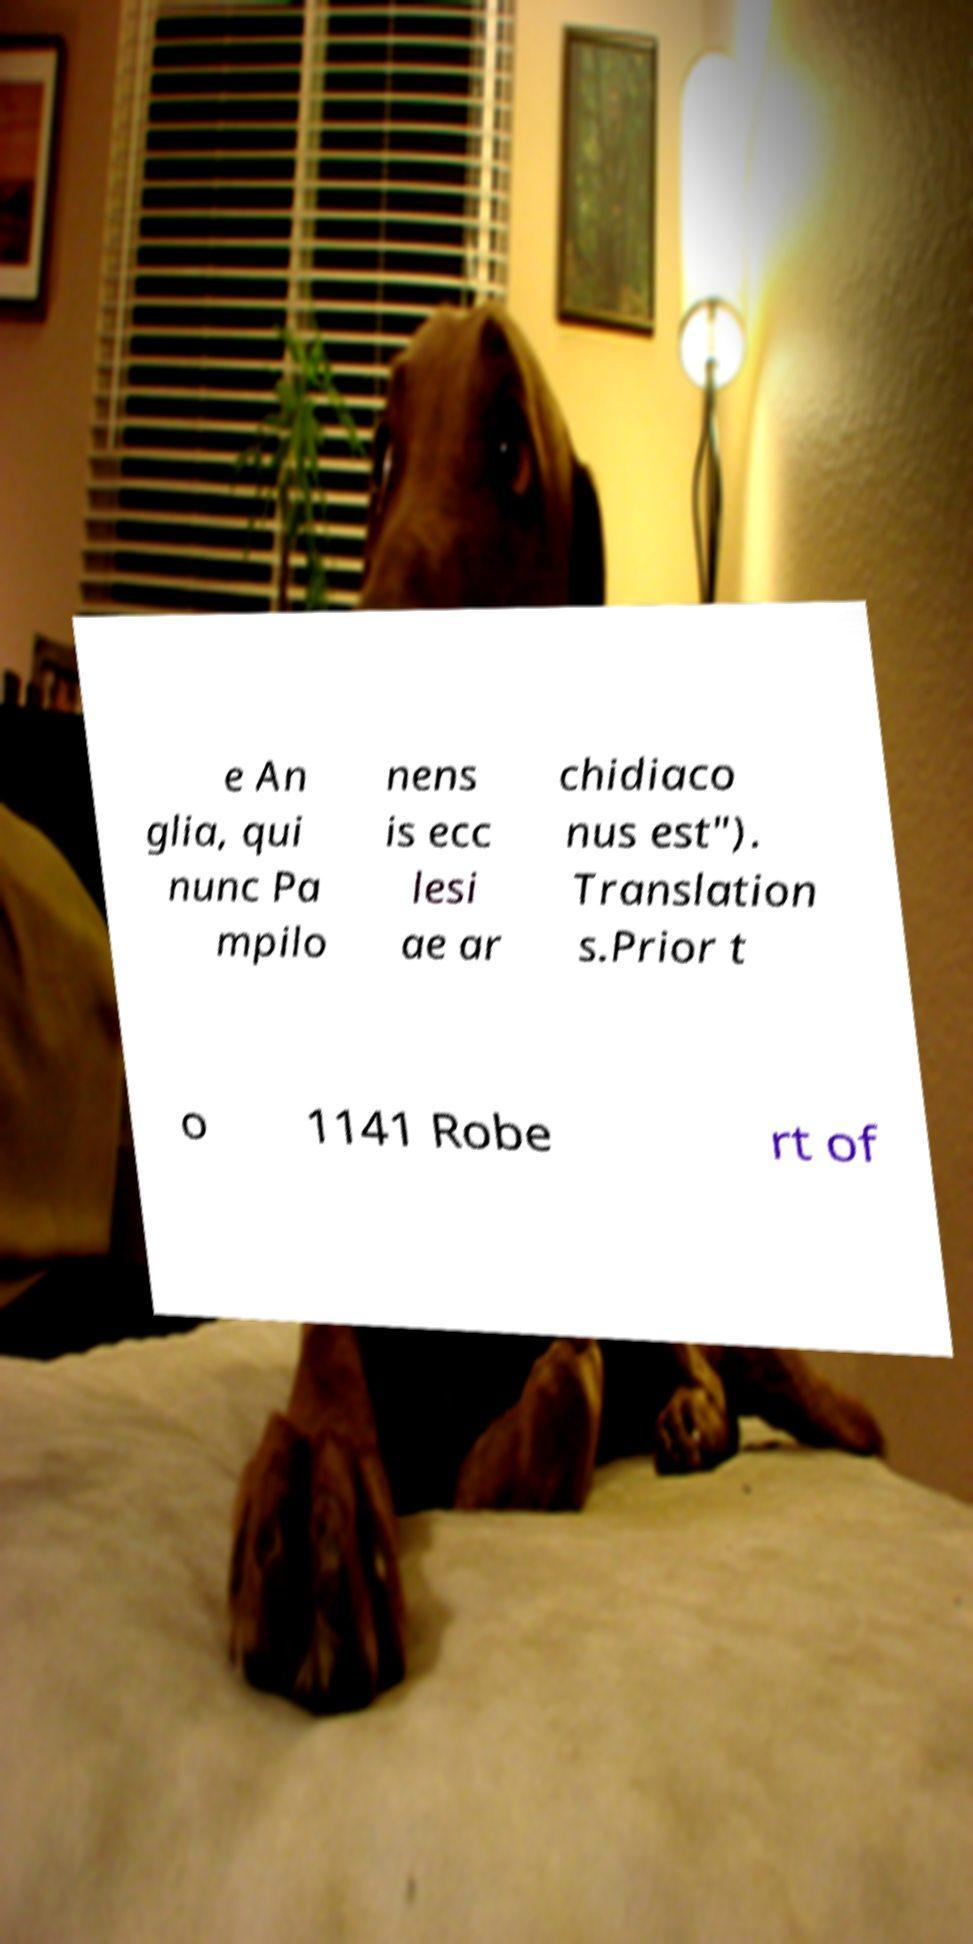What messages or text are displayed in this image? I need them in a readable, typed format. e An glia, qui nunc Pa mpilo nens is ecc lesi ae ar chidiaco nus est"). Translation s.Prior t o 1141 Robe rt of 